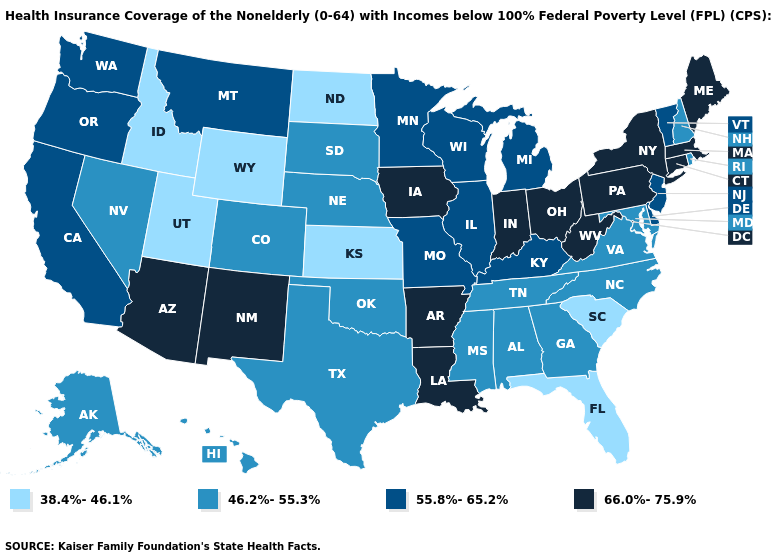Does the first symbol in the legend represent the smallest category?
Answer briefly. Yes. What is the value of Maine?
Answer briefly. 66.0%-75.9%. Name the states that have a value in the range 38.4%-46.1%?
Quick response, please. Florida, Idaho, Kansas, North Dakota, South Carolina, Utah, Wyoming. What is the lowest value in the USA?
Short answer required. 38.4%-46.1%. Does Alabama have the highest value in the South?
Keep it brief. No. Name the states that have a value in the range 66.0%-75.9%?
Concise answer only. Arizona, Arkansas, Connecticut, Indiana, Iowa, Louisiana, Maine, Massachusetts, New Mexico, New York, Ohio, Pennsylvania, West Virginia. Does the first symbol in the legend represent the smallest category?
Answer briefly. Yes. What is the value of Montana?
Write a very short answer. 55.8%-65.2%. Does Indiana have the highest value in the USA?
Quick response, please. Yes. What is the highest value in the West ?
Concise answer only. 66.0%-75.9%. Among the states that border Massachusetts , which have the highest value?
Be succinct. Connecticut, New York. Does Vermont have the highest value in the Northeast?
Short answer required. No. Name the states that have a value in the range 38.4%-46.1%?
Answer briefly. Florida, Idaho, Kansas, North Dakota, South Carolina, Utah, Wyoming. Name the states that have a value in the range 38.4%-46.1%?
Be succinct. Florida, Idaho, Kansas, North Dakota, South Carolina, Utah, Wyoming. Does the map have missing data?
Be succinct. No. 